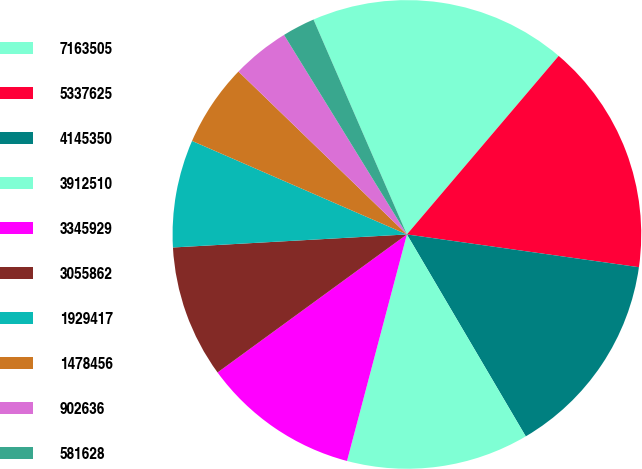<chart> <loc_0><loc_0><loc_500><loc_500><pie_chart><fcel>7163505<fcel>5337625<fcel>4145350<fcel>3912510<fcel>3345929<fcel>3055862<fcel>1929417<fcel>1478456<fcel>902636<fcel>581628<nl><fcel>17.74%<fcel>16.02%<fcel>14.3%<fcel>12.58%<fcel>10.86%<fcel>9.14%<fcel>7.42%<fcel>5.7%<fcel>3.98%<fcel>2.26%<nl></chart> 